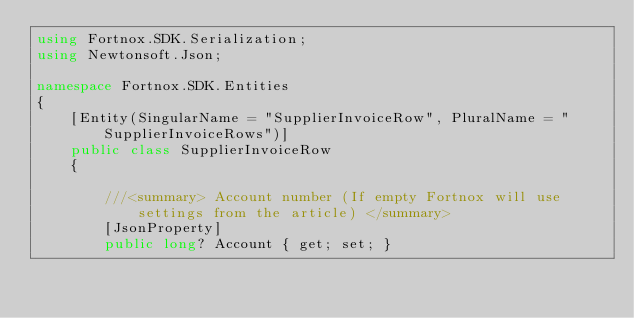Convert code to text. <code><loc_0><loc_0><loc_500><loc_500><_C#_>using Fortnox.SDK.Serialization;
using Newtonsoft.Json;

namespace Fortnox.SDK.Entities
{
    [Entity(SingularName = "SupplierInvoiceRow", PluralName = "SupplierInvoiceRows")]
    public class SupplierInvoiceRow
    {

        ///<summary> Account number (If empty Fortnox will use settings from the article) </summary>
        [JsonProperty]
        public long? Account { get; set; }
</code> 